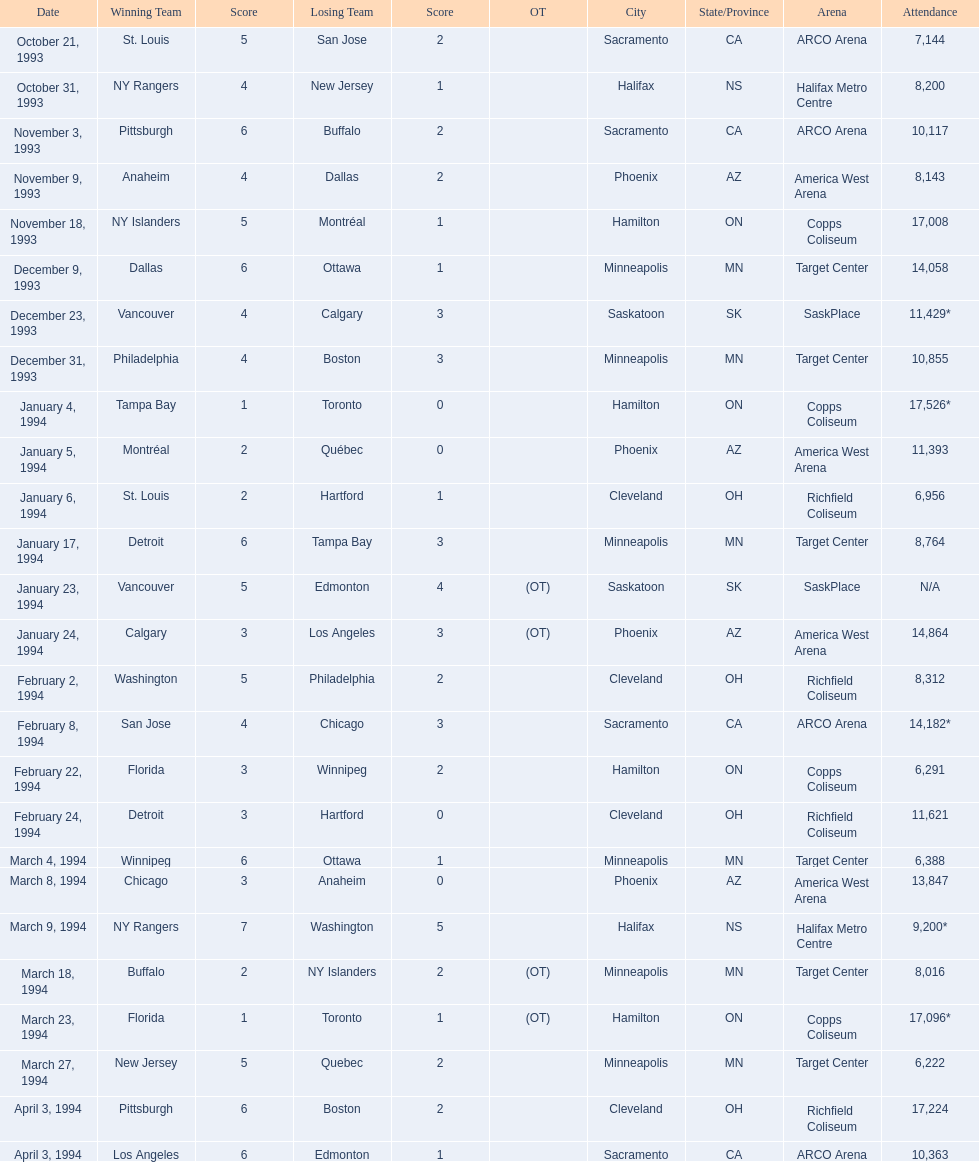What was the number of people present on january 24, 1994? 14,864. How many individuals were present on december 23, 1993? 11,429*. Between these two dates, which one had a larger attendance? January 4, 1994. 